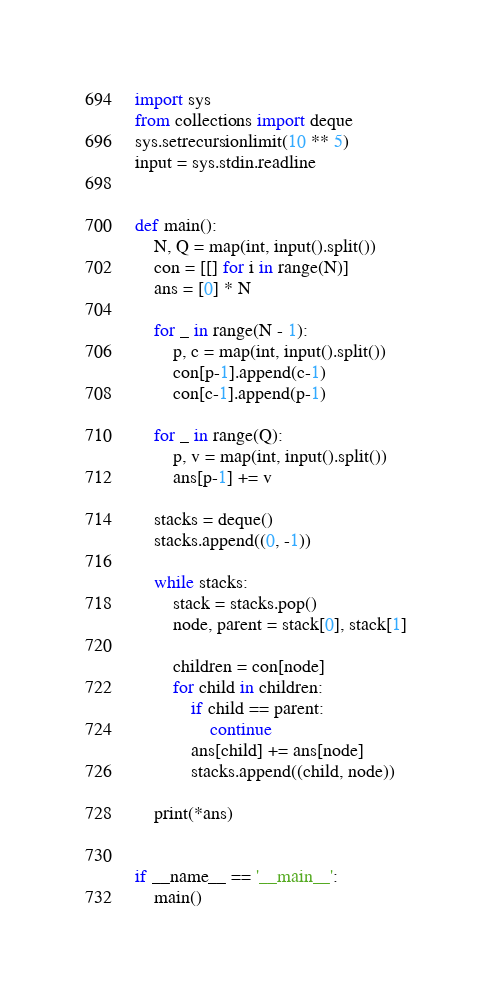<code> <loc_0><loc_0><loc_500><loc_500><_Python_>import sys
from collections import deque
sys.setrecursionlimit(10 ** 5)
input = sys.stdin.readline


def main():
    N, Q = map(int, input().split())
    con = [[] for i in range(N)]
    ans = [0] * N

    for _ in range(N - 1):
        p, c = map(int, input().split())
        con[p-1].append(c-1)
        con[c-1].append(p-1)

    for _ in range(Q):
        p, v = map(int, input().split())
        ans[p-1] += v

    stacks = deque()
    stacks.append((0, -1))

    while stacks:
        stack = stacks.pop()
        node, parent = stack[0], stack[1]

        children = con[node]
        for child in children:
            if child == parent:
                continue
            ans[child] += ans[node]
            stacks.append((child, node))

    print(*ans)


if __name__ == '__main__':
    main()
</code> 